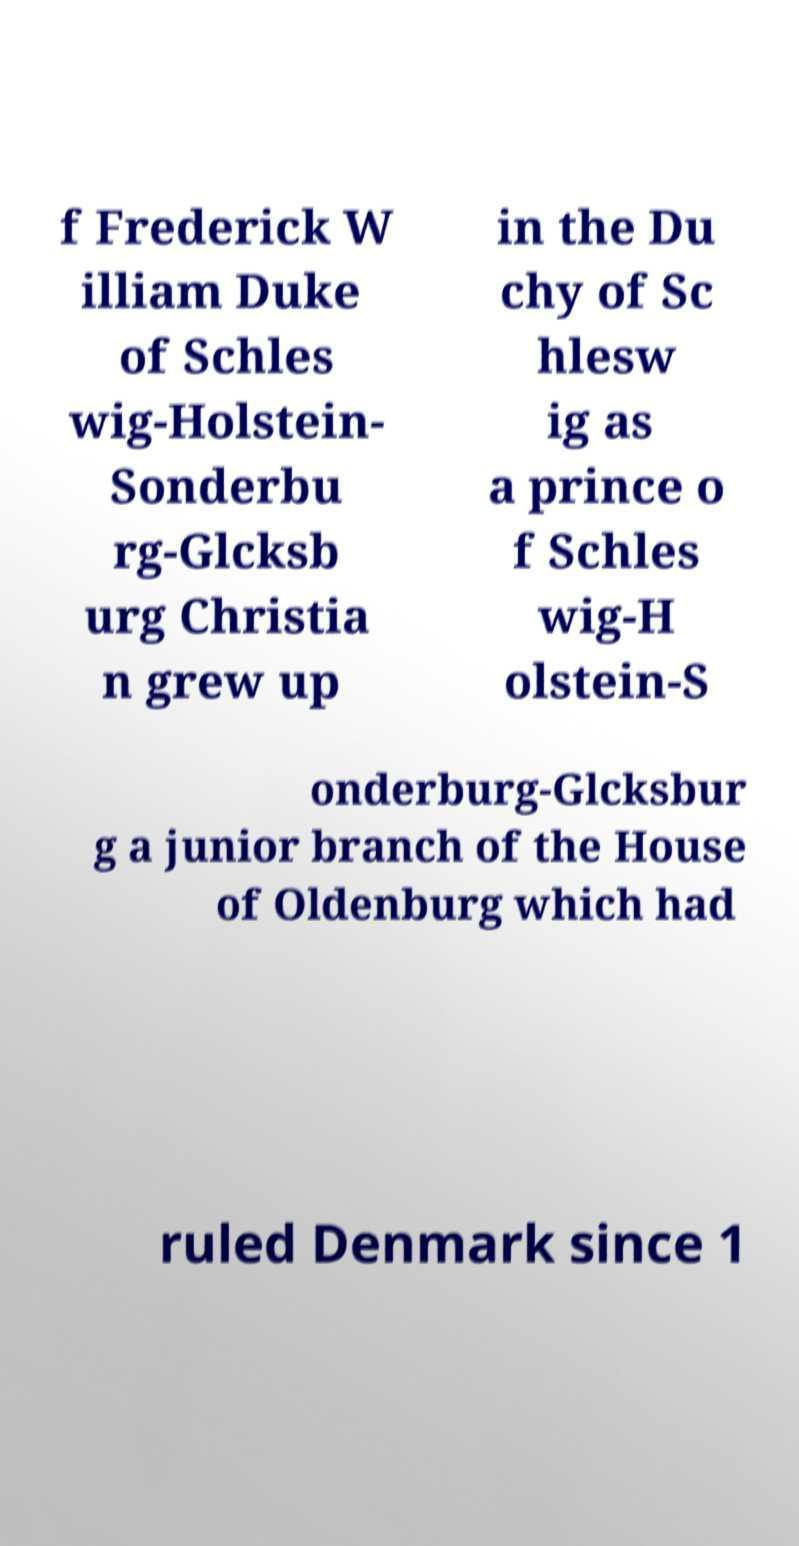Could you assist in decoding the text presented in this image and type it out clearly? f Frederick W illiam Duke of Schles wig-Holstein- Sonderbu rg-Glcksb urg Christia n grew up in the Du chy of Sc hlesw ig as a prince o f Schles wig-H olstein-S onderburg-Glcksbur g a junior branch of the House of Oldenburg which had ruled Denmark since 1 